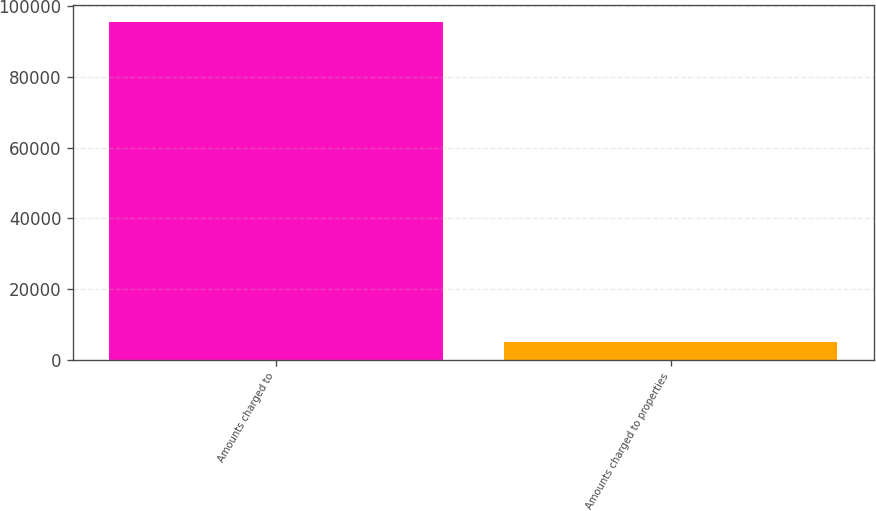Convert chart. <chart><loc_0><loc_0><loc_500><loc_500><bar_chart><fcel>Amounts charged to<fcel>Amounts charged to properties<nl><fcel>95564<fcel>5049<nl></chart> 